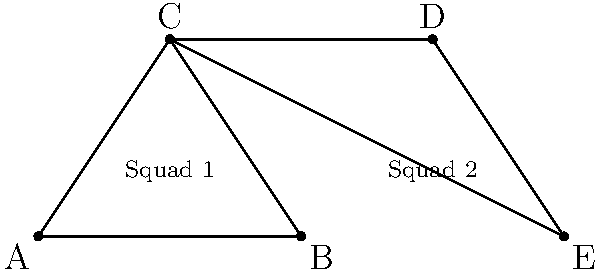In the military formation diagram, two squads are positioned in triangular formations. Identify which two triangles are congruent and explain the criteria used to determine congruence. To determine if the triangles are congruent, we need to examine the three criteria for triangle congruence: SSS (Side-Side-Side), SAS (Side-Angle-Side), or ASA (Angle-Side-Angle). Let's analyze the triangles step-by-step:

1. Triangle ABC represents Squad 1's formation.
2. Triangle CDE represents Squad 2's formation.

3. Observe that:
   - AC = CD (both are sides of the overall rectangle)
   - AB = DE (bases of both triangles are equal)
   - ∠CAB = ∠DCE (alternate interior angles formed by the parallel lines AC and DE)

4. We can conclude that triangles ABC and CDE are congruent by the SAS (Side-Angle-Side) criterion:
   - Side AB ≅ Side DE
   - ∠CAB ≅ ∠DCE
   - Side AC ≅ Side CD

5. In military terms, this congruence ensures that both squads maintain identical formations, which is crucial for coordinated movements and maintaining unit cohesion during operations.
Answer: Triangles ABC and CDE are congruent by SAS criterion. 